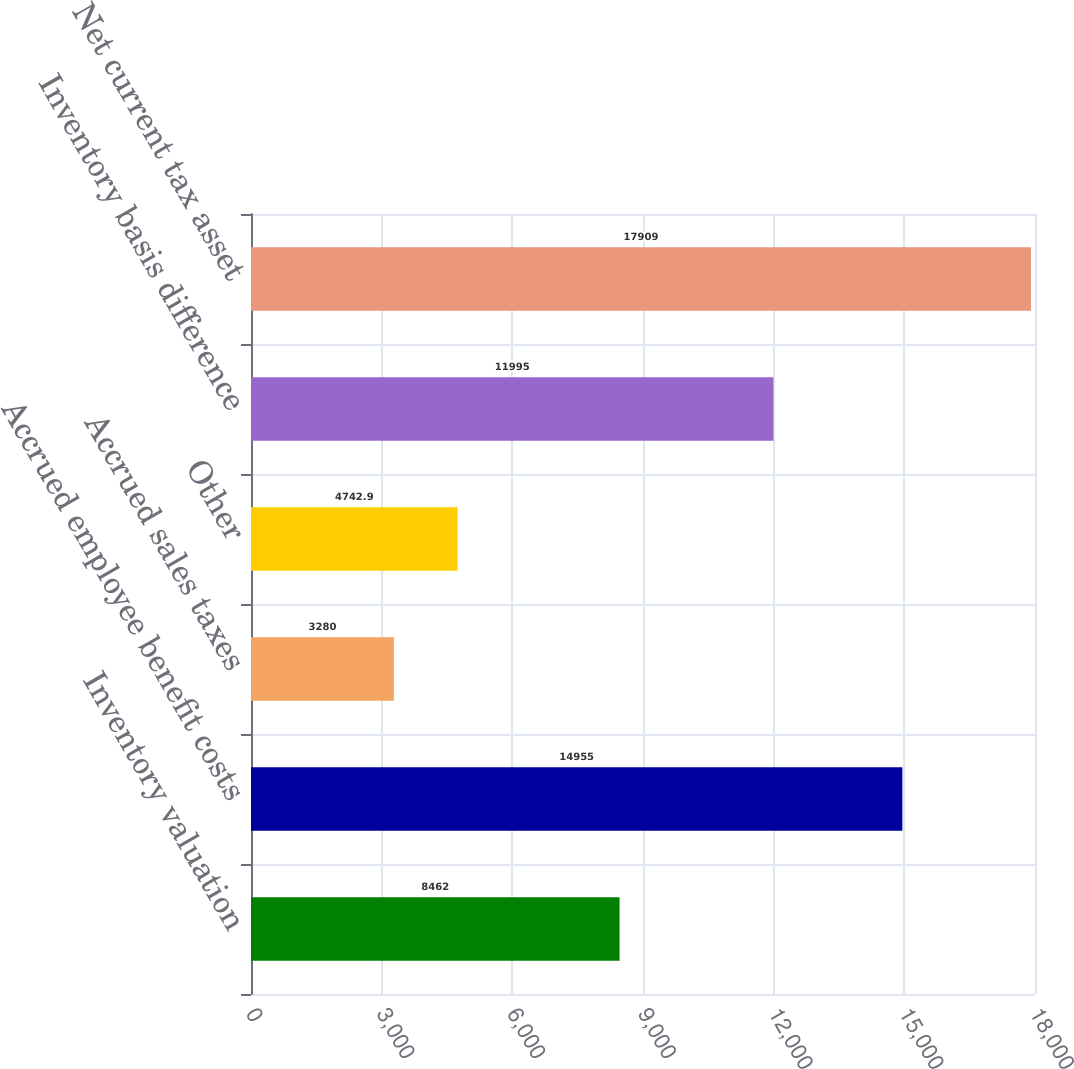Convert chart. <chart><loc_0><loc_0><loc_500><loc_500><bar_chart><fcel>Inventory valuation<fcel>Accrued employee benefit costs<fcel>Accrued sales taxes<fcel>Other<fcel>Inventory basis difference<fcel>Net current tax asset<nl><fcel>8462<fcel>14955<fcel>3280<fcel>4742.9<fcel>11995<fcel>17909<nl></chart> 